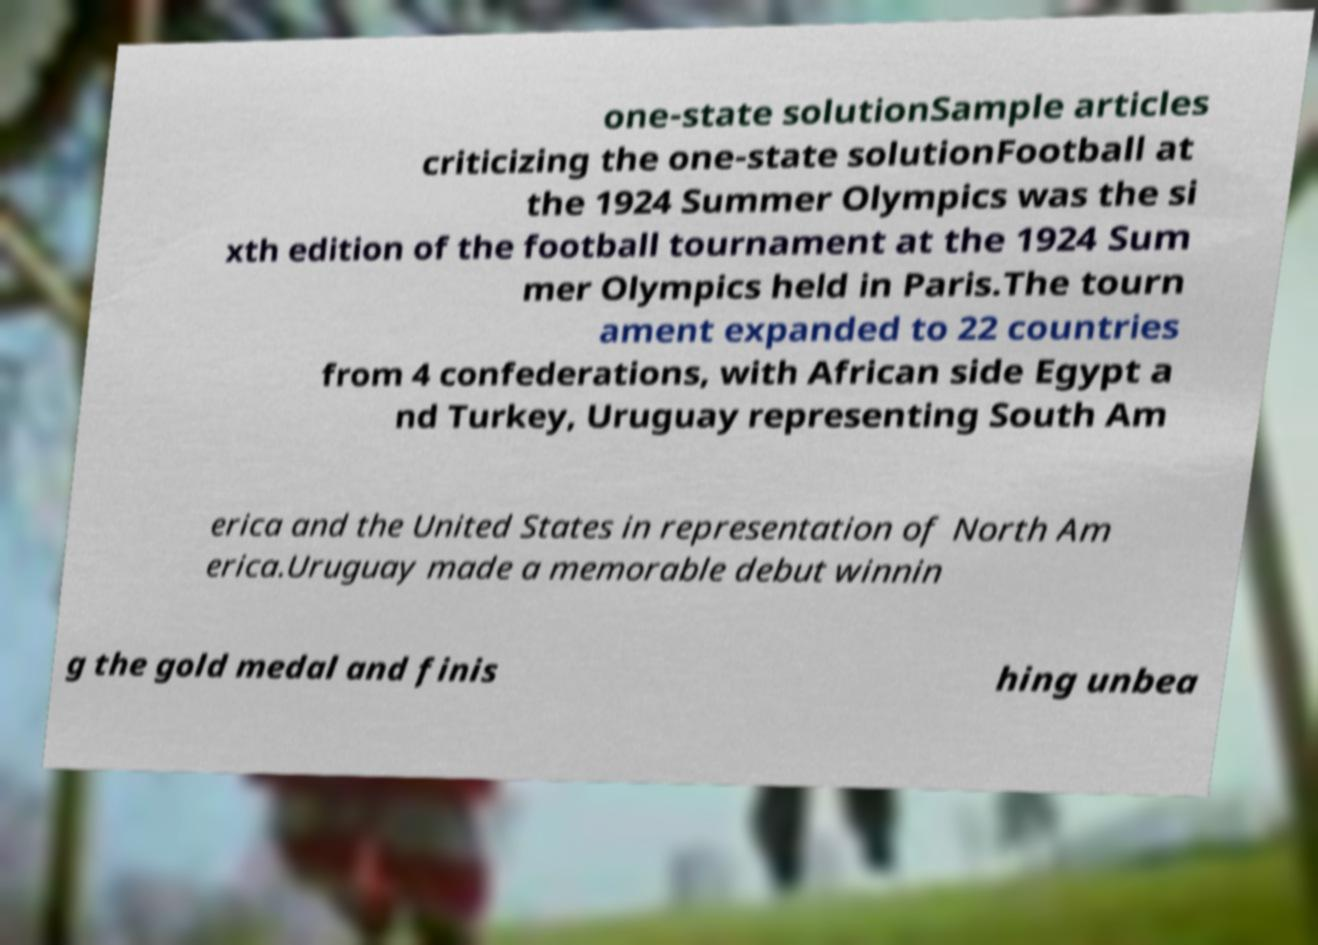Please identify and transcribe the text found in this image. one-state solutionSample articles criticizing the one-state solutionFootball at the 1924 Summer Olympics was the si xth edition of the football tournament at the 1924 Sum mer Olympics held in Paris.The tourn ament expanded to 22 countries from 4 confederations, with African side Egypt a nd Turkey, Uruguay representing South Am erica and the United States in representation of North Am erica.Uruguay made a memorable debut winnin g the gold medal and finis hing unbea 